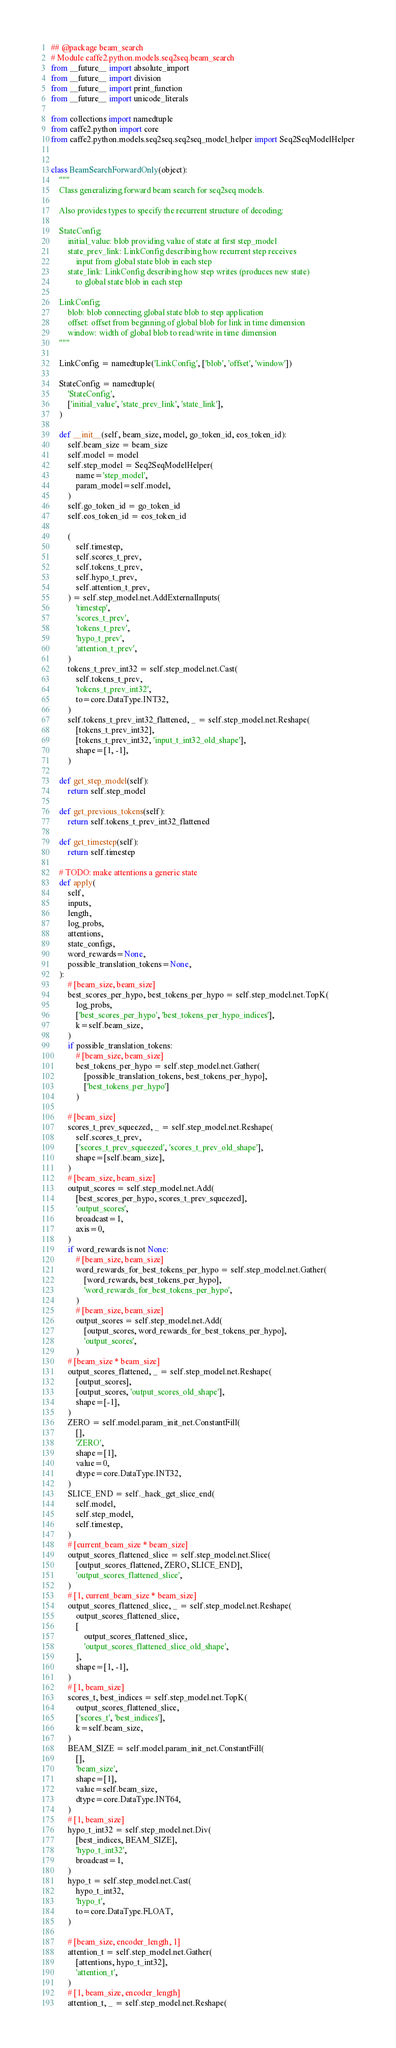Convert code to text. <code><loc_0><loc_0><loc_500><loc_500><_Python_>## @package beam_search
# Module caffe2.python.models.seq2seq.beam_search
from __future__ import absolute_import
from __future__ import division
from __future__ import print_function
from __future__ import unicode_literals

from collections import namedtuple
from caffe2.python import core
from caffe2.python.models.seq2seq.seq2seq_model_helper import Seq2SeqModelHelper


class BeamSearchForwardOnly(object):
    """
    Class generalizing forward beam search for seq2seq models.

    Also provides types to specify the recurrent structure of decoding:

    StateConfig:
        initial_value: blob providing value of state at first step_model
        state_prev_link: LinkConfig describing how recurrent step receives
            input from global state blob in each step
        state_link: LinkConfig describing how step writes (produces new state)
            to global state blob in each step

    LinkConfig:
        blob: blob connecting global state blob to step application
        offset: offset from beginning of global blob for link in time dimension
        window: width of global blob to read/write in time dimension
    """

    LinkConfig = namedtuple('LinkConfig', ['blob', 'offset', 'window'])

    StateConfig = namedtuple(
        'StateConfig',
        ['initial_value', 'state_prev_link', 'state_link'],
    )

    def __init__(self, beam_size, model, go_token_id, eos_token_id):
        self.beam_size = beam_size
        self.model = model
        self.step_model = Seq2SeqModelHelper(
            name='step_model',
            param_model=self.model,
        )
        self.go_token_id = go_token_id
        self.eos_token_id = eos_token_id

        (
            self.timestep,
            self.scores_t_prev,
            self.tokens_t_prev,
            self.hypo_t_prev,
            self.attention_t_prev,
        ) = self.step_model.net.AddExternalInputs(
            'timestep',
            'scores_t_prev',
            'tokens_t_prev',
            'hypo_t_prev',
            'attention_t_prev',
        )
        tokens_t_prev_int32 = self.step_model.net.Cast(
            self.tokens_t_prev,
            'tokens_t_prev_int32',
            to=core.DataType.INT32,
        )
        self.tokens_t_prev_int32_flattened, _ = self.step_model.net.Reshape(
            [tokens_t_prev_int32],
            [tokens_t_prev_int32, 'input_t_int32_old_shape'],
            shape=[1, -1],
        )

    def get_step_model(self):
        return self.step_model

    def get_previous_tokens(self):
        return self.tokens_t_prev_int32_flattened

    def get_timestep(self):
        return self.timestep

    # TODO: make attentions a generic state
    def apply(
        self,
        inputs,
        length,
        log_probs,
        attentions,
        state_configs,
        word_rewards=None,
        possible_translation_tokens=None,
    ):
        # [beam_size, beam_size]
        best_scores_per_hypo, best_tokens_per_hypo = self.step_model.net.TopK(
            log_probs,
            ['best_scores_per_hypo', 'best_tokens_per_hypo_indices'],
            k=self.beam_size,
        )
        if possible_translation_tokens:
            # [beam_size, beam_size]
            best_tokens_per_hypo = self.step_model.net.Gather(
                [possible_translation_tokens, best_tokens_per_hypo],
                ['best_tokens_per_hypo']
            )

        # [beam_size]
        scores_t_prev_squeezed, _ = self.step_model.net.Reshape(
            self.scores_t_prev,
            ['scores_t_prev_squeezed', 'scores_t_prev_old_shape'],
            shape=[self.beam_size],
        )
        # [beam_size, beam_size]
        output_scores = self.step_model.net.Add(
            [best_scores_per_hypo, scores_t_prev_squeezed],
            'output_scores',
            broadcast=1,
            axis=0,
        )
        if word_rewards is not None:
            # [beam_size, beam_size]
            word_rewards_for_best_tokens_per_hypo = self.step_model.net.Gather(
                [word_rewards, best_tokens_per_hypo],
                'word_rewards_for_best_tokens_per_hypo',
            )
            # [beam_size, beam_size]
            output_scores = self.step_model.net.Add(
                [output_scores, word_rewards_for_best_tokens_per_hypo],
                'output_scores',
            )
        # [beam_size * beam_size]
        output_scores_flattened, _ = self.step_model.net.Reshape(
            [output_scores],
            [output_scores, 'output_scores_old_shape'],
            shape=[-1],
        )
        ZERO = self.model.param_init_net.ConstantFill(
            [],
            'ZERO',
            shape=[1],
            value=0,
            dtype=core.DataType.INT32,
        )
        SLICE_END = self._hack_get_slice_end(
            self.model,
            self.step_model,
            self.timestep,
        )
        # [current_beam_size * beam_size]
        output_scores_flattened_slice = self.step_model.net.Slice(
            [output_scores_flattened, ZERO, SLICE_END],
            'output_scores_flattened_slice',
        )
        # [1, current_beam_size * beam_size]
        output_scores_flattened_slice, _ = self.step_model.net.Reshape(
            output_scores_flattened_slice,
            [
                output_scores_flattened_slice,
                'output_scores_flattened_slice_old_shape',
            ],
            shape=[1, -1],
        )
        # [1, beam_size]
        scores_t, best_indices = self.step_model.net.TopK(
            output_scores_flattened_slice,
            ['scores_t', 'best_indices'],
            k=self.beam_size,
        )
        BEAM_SIZE = self.model.param_init_net.ConstantFill(
            [],
            'beam_size',
            shape=[1],
            value=self.beam_size,
            dtype=core.DataType.INT64,
        )
        # [1, beam_size]
        hypo_t_int32 = self.step_model.net.Div(
            [best_indices, BEAM_SIZE],
            'hypo_t_int32',
            broadcast=1,
        )
        hypo_t = self.step_model.net.Cast(
            hypo_t_int32,
            'hypo_t',
            to=core.DataType.FLOAT,
        )

        # [beam_size, encoder_length, 1]
        attention_t = self.step_model.net.Gather(
            [attentions, hypo_t_int32],
            'attention_t',
        )
        # [1, beam_size, encoder_length]
        attention_t, _ = self.step_model.net.Reshape(</code> 